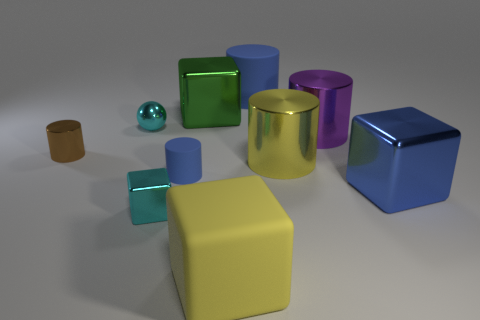Subtract 3 cylinders. How many cylinders are left? 2 Subtract all small blue matte cylinders. How many cylinders are left? 4 Subtract all brown cylinders. How many cylinders are left? 4 Subtract all brown cubes. Subtract all blue cylinders. How many cubes are left? 4 Subtract all balls. How many objects are left? 9 Add 1 blue shiny blocks. How many blue shiny blocks exist? 2 Subtract 0 brown spheres. How many objects are left? 10 Subtract all cylinders. Subtract all big red metallic objects. How many objects are left? 5 Add 9 yellow blocks. How many yellow blocks are left? 10 